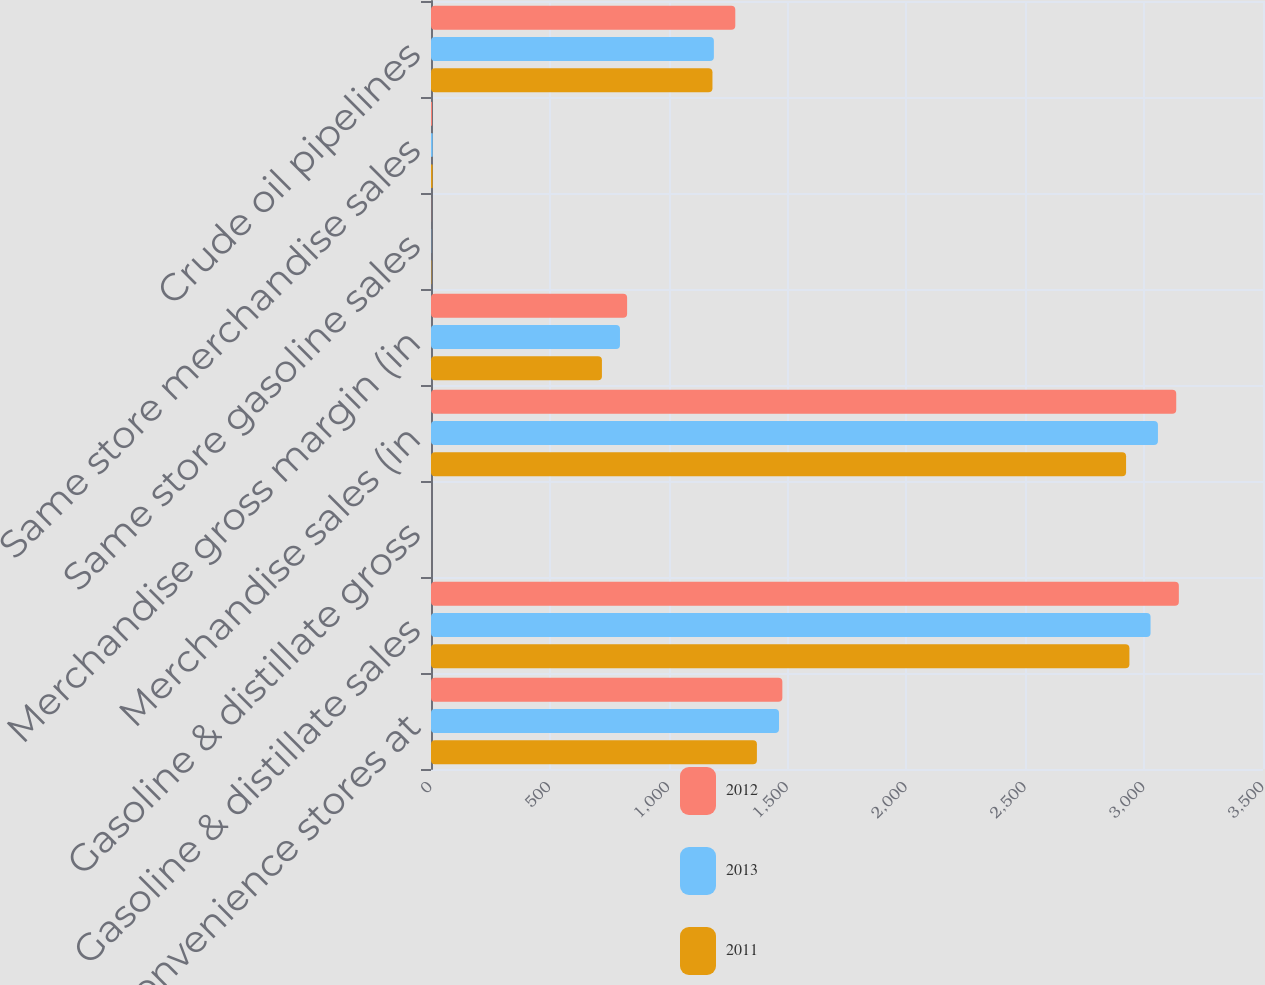<chart> <loc_0><loc_0><loc_500><loc_500><stacked_bar_chart><ecel><fcel>Convenience stores at<fcel>Gasoline & distillate sales<fcel>Gasoline & distillate gross<fcel>Merchandise sales (in<fcel>Merchandise gross margin (in<fcel>Same store gasoline sales<fcel>Same store merchandise sales<fcel>Crude oil pipelines<nl><fcel>2012<fcel>1478<fcel>3146<fcel>0.14<fcel>3135<fcel>825<fcel>0.5<fcel>4.3<fcel>1280<nl><fcel>2013<fcel>1464<fcel>3027<fcel>0.13<fcel>3058<fcel>795<fcel>0.8<fcel>7<fcel>1190<nl><fcel>2011<fcel>1371<fcel>2938<fcel>0.13<fcel>2924<fcel>719<fcel>1.7<fcel>6.7<fcel>1184<nl></chart> 